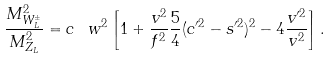<formula> <loc_0><loc_0><loc_500><loc_500>\frac { M _ { W _ { L } ^ { \pm } } ^ { 2 } } { M _ { Z _ { L } } ^ { 2 } } = c _ { \ } w ^ { 2 } \left [ 1 + \frac { v ^ { 2 } } { f ^ { 2 } } \frac { 5 } { 4 } ( c ^ { \prime 2 } - s ^ { \prime 2 } ) ^ { 2 } - 4 \frac { v ^ { \prime 2 } } { v ^ { 2 } } \right ] .</formula> 